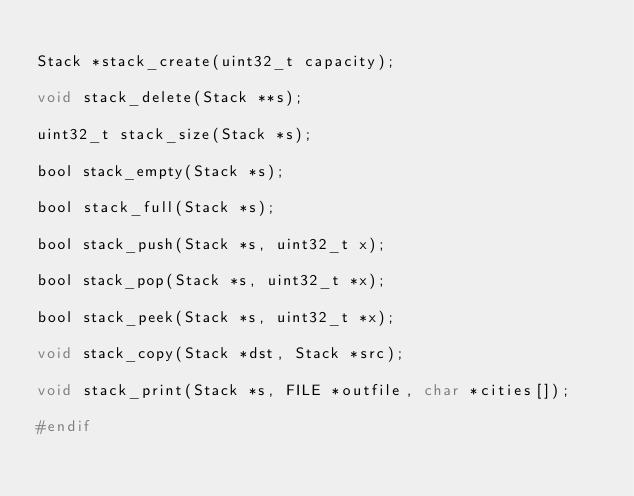Convert code to text. <code><loc_0><loc_0><loc_500><loc_500><_C_>
Stack *stack_create(uint32_t capacity);

void stack_delete(Stack **s);

uint32_t stack_size(Stack *s);

bool stack_empty(Stack *s);

bool stack_full(Stack *s);

bool stack_push(Stack *s, uint32_t x);

bool stack_pop(Stack *s, uint32_t *x);

bool stack_peek(Stack *s, uint32_t *x);

void stack_copy(Stack *dst, Stack *src);

void stack_print(Stack *s, FILE *outfile, char *cities[]);

#endif
</code> 